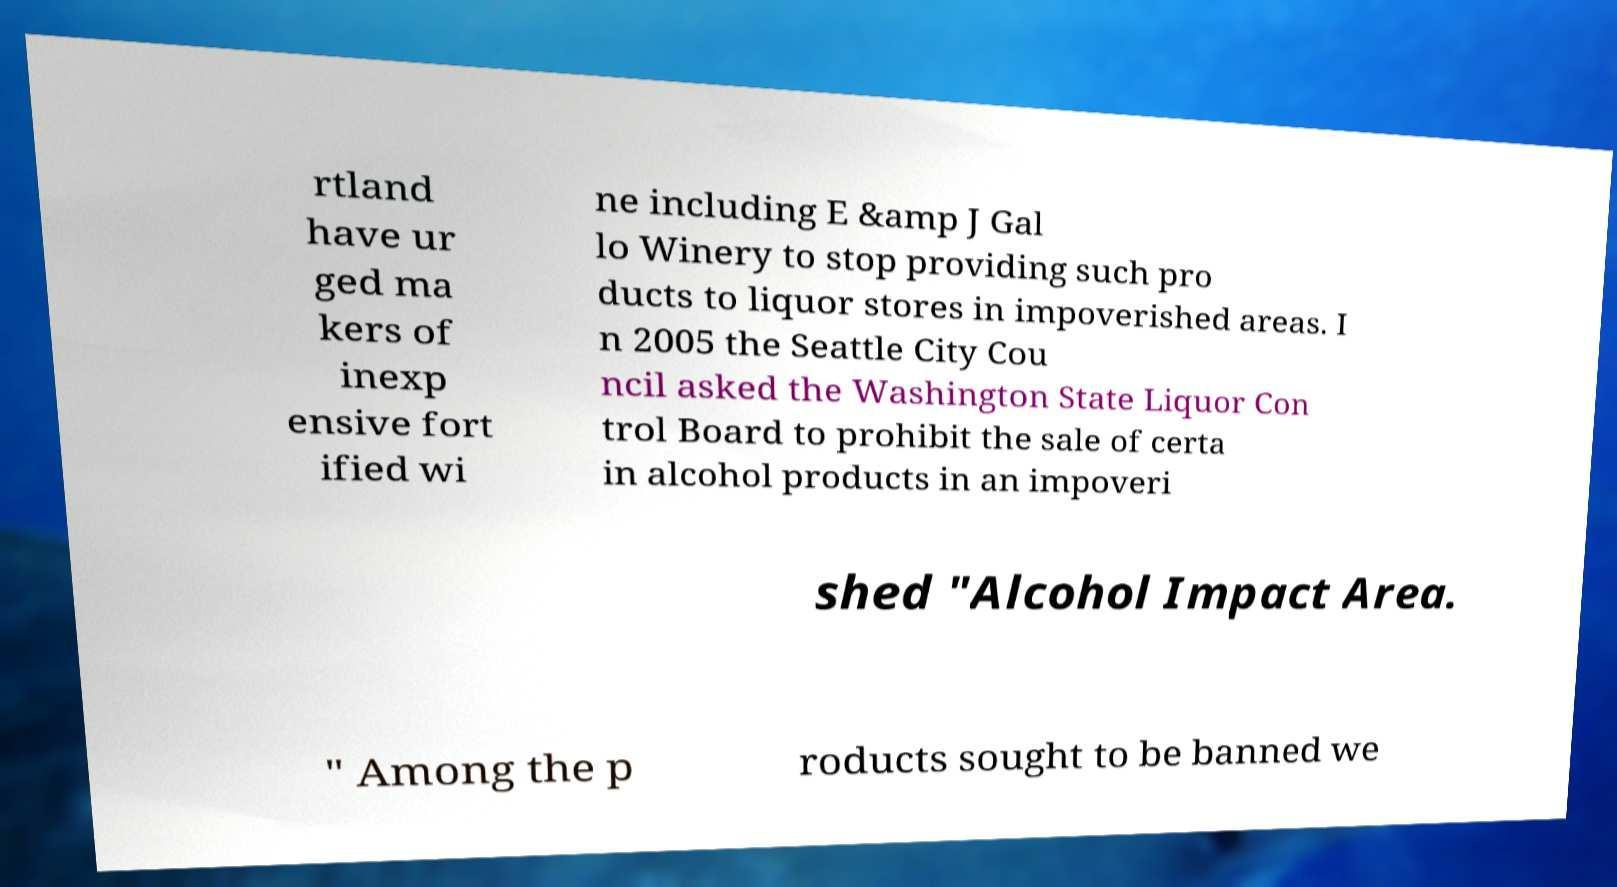I need the written content from this picture converted into text. Can you do that? rtland have ur ged ma kers of inexp ensive fort ified wi ne including E &amp J Gal lo Winery to stop providing such pro ducts to liquor stores in impoverished areas. I n 2005 the Seattle City Cou ncil asked the Washington State Liquor Con trol Board to prohibit the sale of certa in alcohol products in an impoveri shed "Alcohol Impact Area. " Among the p roducts sought to be banned we 